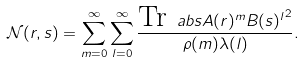Convert formula to latex. <formula><loc_0><loc_0><loc_500><loc_500>\mathcal { N } ( r , s ) = \sum _ { m = 0 } ^ { \infty } \sum _ { l = 0 } ^ { \infty } \frac { \text {Tr} \ a b s { A ( r ) ^ { m } B ( s ) ^ { l } } ^ { 2 } } { \rho ( m ) \lambda ( l ) } .</formula> 